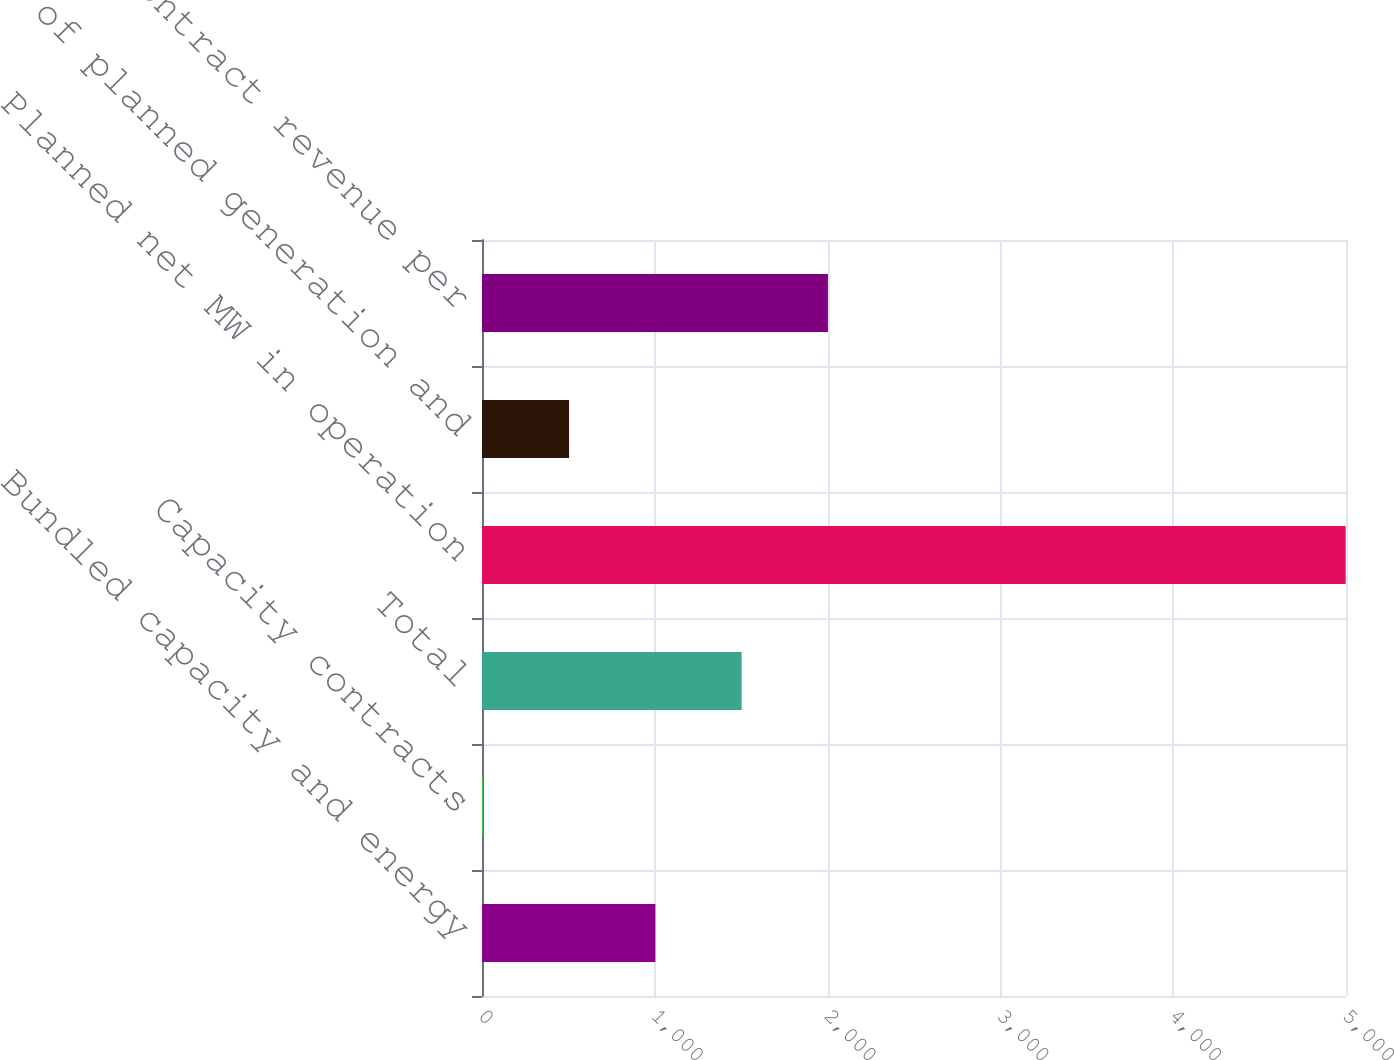Convert chart. <chart><loc_0><loc_0><loc_500><loc_500><bar_chart><fcel>Bundled capacity and energy<fcel>Capacity contracts<fcel>Total<fcel>Planned net MW in operation<fcel>of planned generation and<fcel>Average contract revenue per<nl><fcel>1003.28<fcel>4.6<fcel>1502.62<fcel>4998<fcel>503.94<fcel>2001.96<nl></chart> 